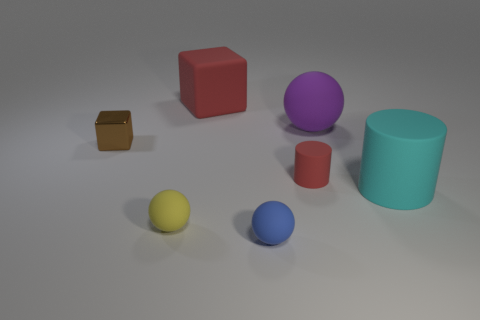Subtract all big purple matte balls. How many balls are left? 2 Subtract all cyan cylinders. How many cylinders are left? 1 Add 1 large rubber balls. How many objects exist? 8 Subtract all purple objects. Subtract all red rubber cubes. How many objects are left? 5 Add 2 large purple rubber objects. How many large purple rubber objects are left? 3 Add 1 cyan rubber cylinders. How many cyan rubber cylinders exist? 2 Subtract 1 red cylinders. How many objects are left? 6 Subtract all balls. How many objects are left? 4 Subtract 1 balls. How many balls are left? 2 Subtract all gray blocks. Subtract all yellow spheres. How many blocks are left? 2 